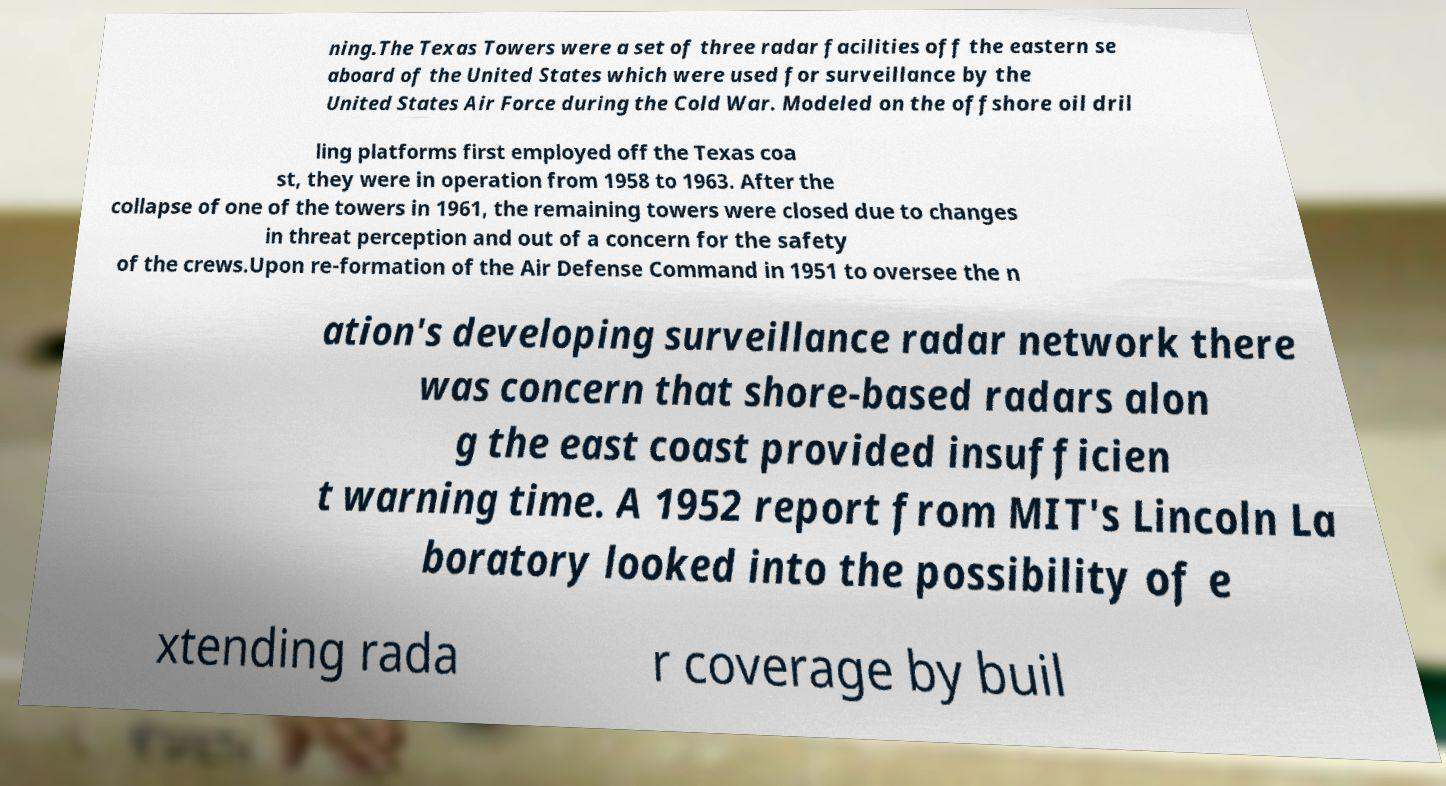What messages or text are displayed in this image? I need them in a readable, typed format. ning.The Texas Towers were a set of three radar facilities off the eastern se aboard of the United States which were used for surveillance by the United States Air Force during the Cold War. Modeled on the offshore oil dril ling platforms first employed off the Texas coa st, they were in operation from 1958 to 1963. After the collapse of one of the towers in 1961, the remaining towers were closed due to changes in threat perception and out of a concern for the safety of the crews.Upon re-formation of the Air Defense Command in 1951 to oversee the n ation's developing surveillance radar network there was concern that shore-based radars alon g the east coast provided insufficien t warning time. A 1952 report from MIT's Lincoln La boratory looked into the possibility of e xtending rada r coverage by buil 